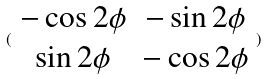Convert formula to latex. <formula><loc_0><loc_0><loc_500><loc_500>( \begin{array} { c c } - \cos 2 \phi & - \sin 2 \phi \\ \sin 2 \phi & - \cos 2 \phi \end{array} )</formula> 